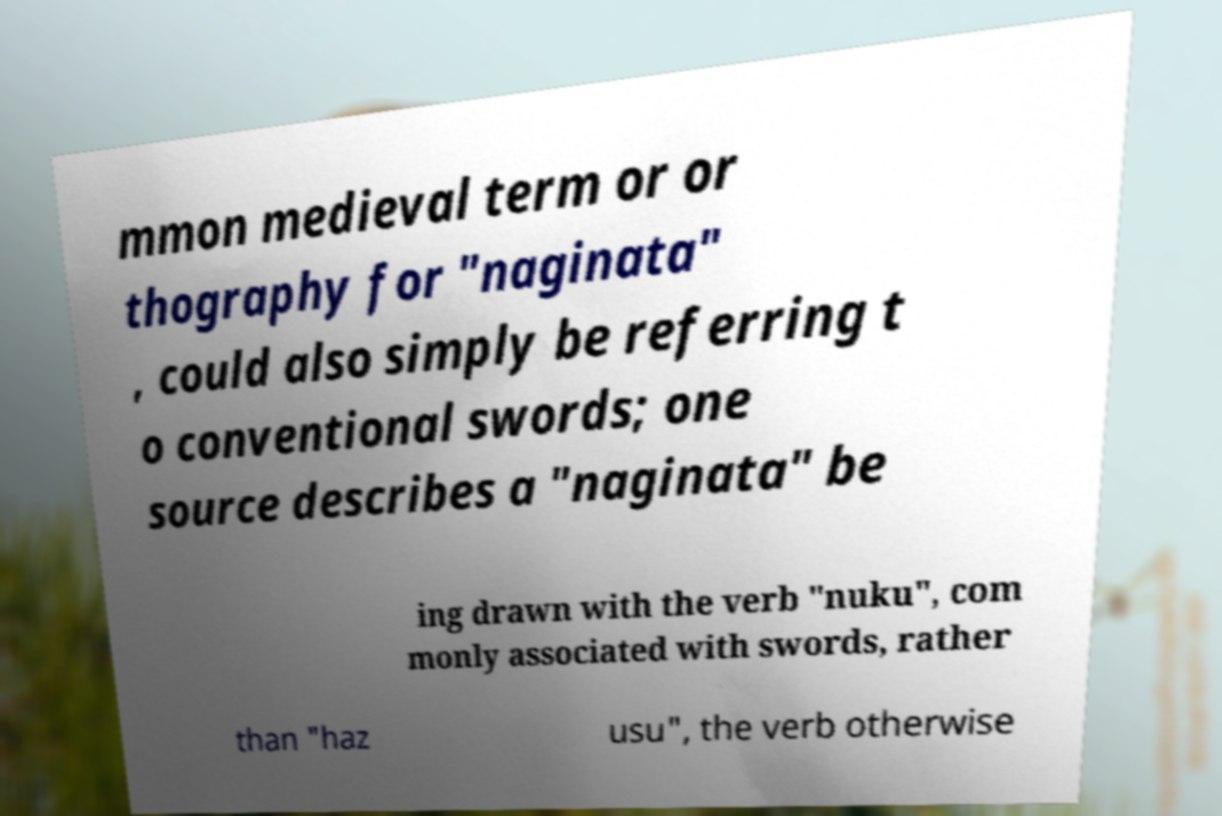Please identify and transcribe the text found in this image. mmon medieval term or or thography for "naginata" , could also simply be referring t o conventional swords; one source describes a "naginata" be ing drawn with the verb "nuku", com monly associated with swords, rather than "haz usu", the verb otherwise 